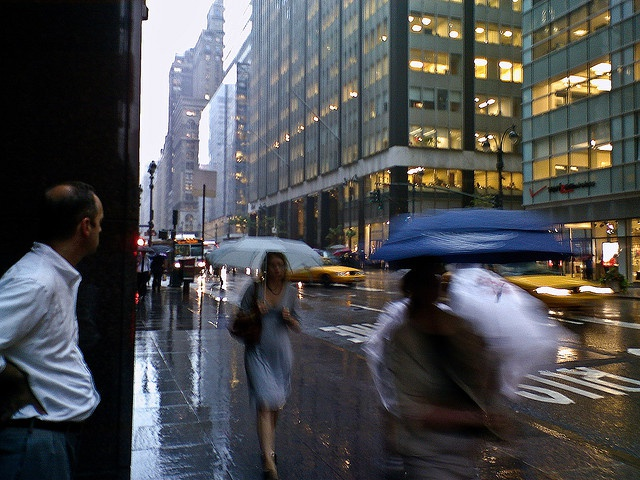Describe the objects in this image and their specific colors. I can see people in black, gray, and darkgray tones, people in black and gray tones, umbrella in black, navy, blue, and darkblue tones, people in black and gray tones, and car in black, maroon, olive, and gray tones in this image. 